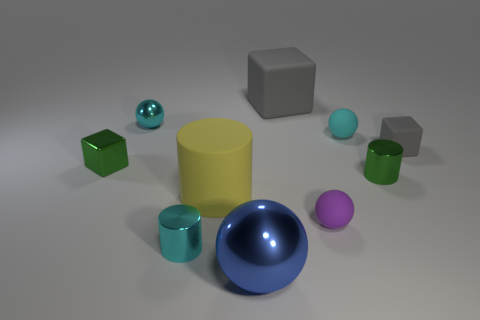What is the size of the gray rubber block behind the rubber cube that is to the right of the large gray block? The gray rubber block positioned behind the green rubber cube, which is to the right of the larger gray block, appears to be relatively small in comparison to the surrounding objects. 